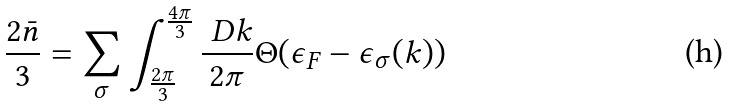<formula> <loc_0><loc_0><loc_500><loc_500>\frac { 2 \bar { n } } 3 = \sum _ { \sigma } \int _ { \frac { 2 \pi } 3 } ^ { \frac { 4 \pi } 3 } \frac { \ D k } { 2 \pi } \Theta ( \epsilon _ { F } - \epsilon _ { \sigma } ( k ) )</formula> 